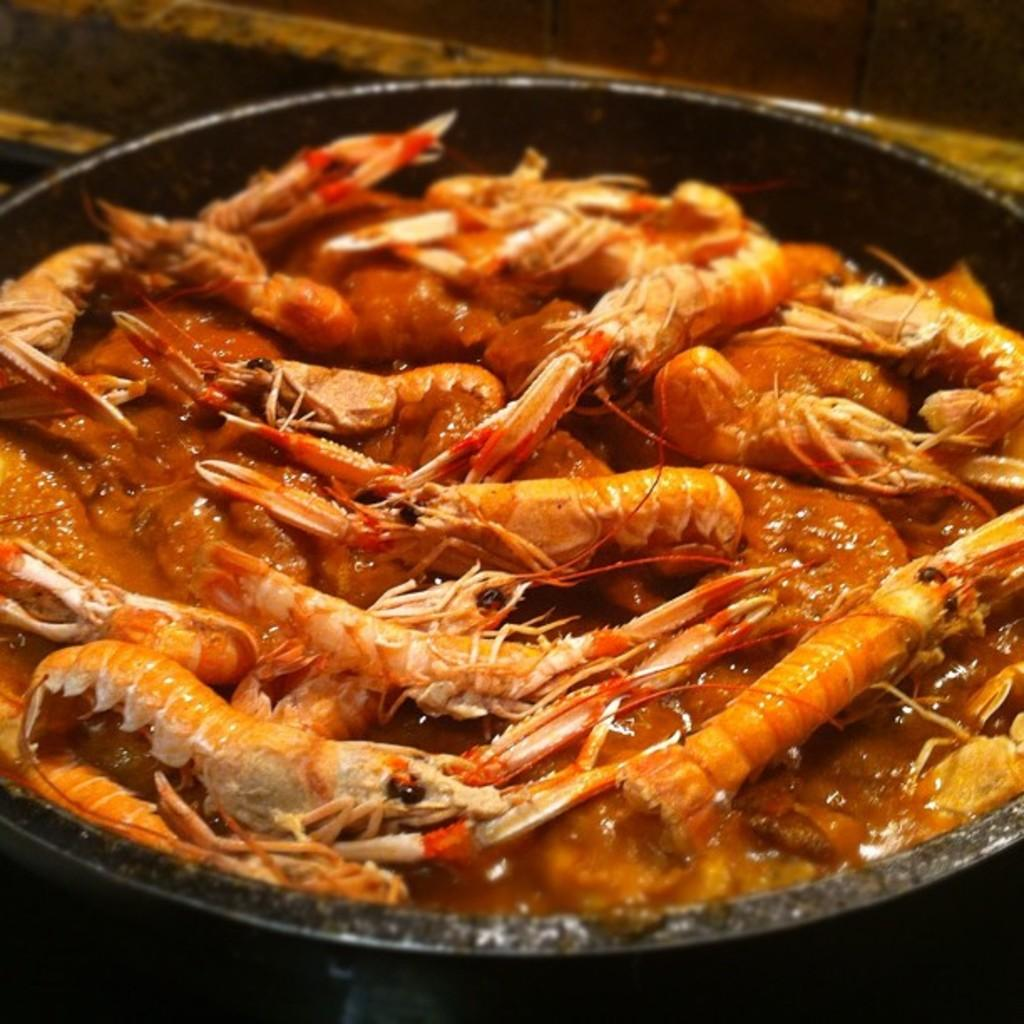What is present in the image? There is a bowl in the image. What is inside the bowl? There is a curry of prawns in the bowl. Who is the governor of the prawns in the image? There is no governor mentioned or implied in the image, as it features a bowl of prawn curry. 